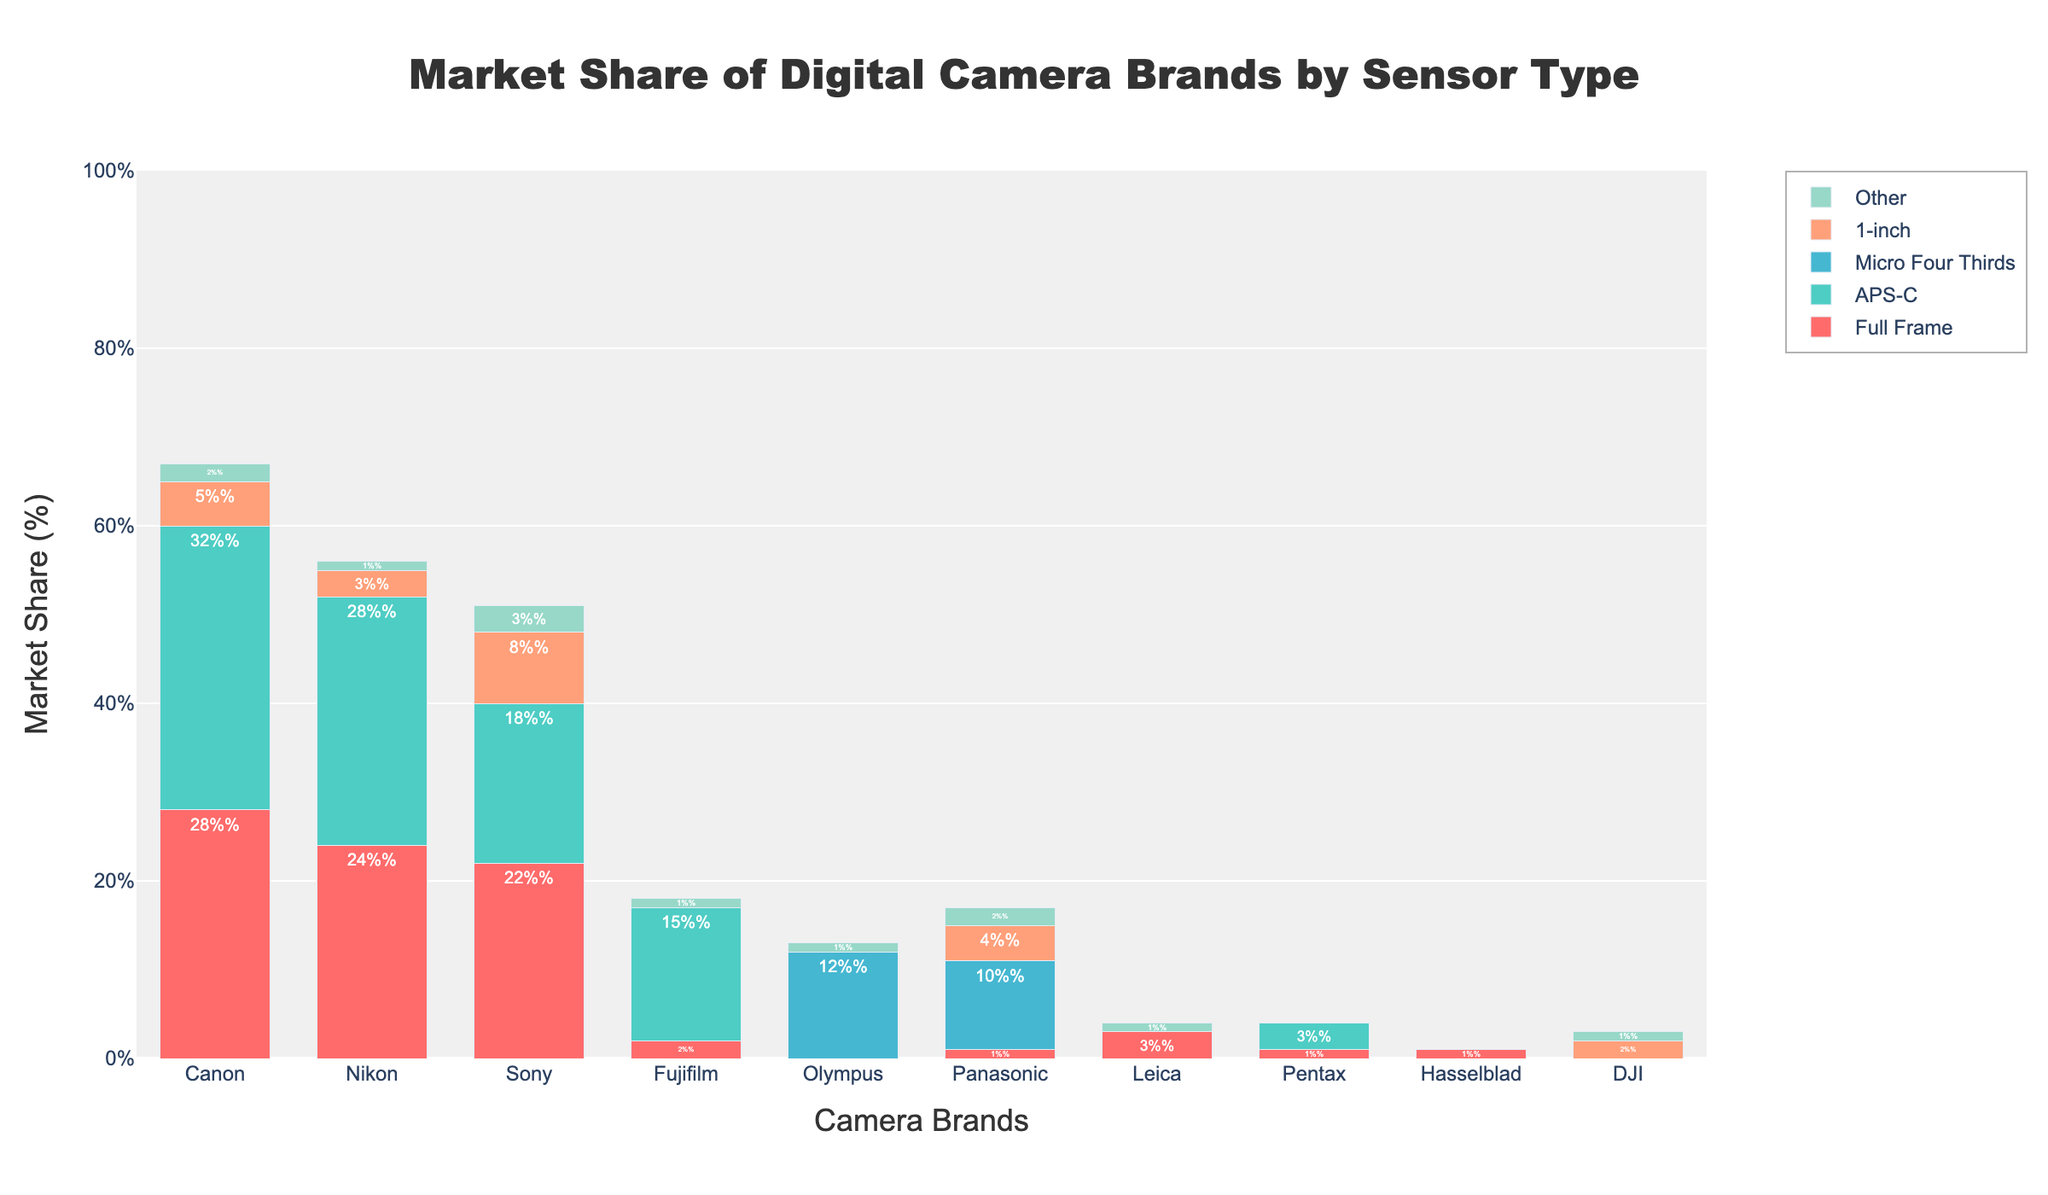Which brand has the largest market share in the Micro Four Thirds sensor type? The **Micro Four Thirds** section of the chart for each brand can be visually compared. Olympus has the tallest bar representing Micro Four Thirds.
Answer: Olympus How many brands offer cameras with Full Frame sensors, and what is the total market share percentage for these brands combined? Count the brands with non-zero Full Frame sections and sum their market shares. The brands are Canon, Nikon, Sony, Fujifilm, Panasonic, Leica, Pentax, and Hasselblad. Their respective shares are 28, 24, 22, 2, 1, 3, 1, and 1, summing up to 82%.
Answer: 8 brands, 82% Which brand has the most diverse range of sensor types, and what are these types? Check for the brand with the most different non-zero sections. Canon has the most diverse range with Full Frame, APS-C, 1-inch, Other sensor types.
Answer: Canon, 4 types Compare the combined market share of 1-inch sensors for Sony and Panasonic. Which brand has a higher share and by how much? Sony's market share in 1-inch is 8%, and Panasonic's is 4%. The difference is 8% - 4% = 4%.
Answer: Sony, 4% higher What is the overall market share of brands that don't offer Full Frame sensors, and which brands are they? Count the brands with zero Full Frame share and sum their overall market shares. Brands: Olympus, DJI. Olympus's overall is 12+1=13% while DJI's is 2+1=3%, so 13 + 3 = 16%.
Answer: 16%, brands are Olympus and DJI 